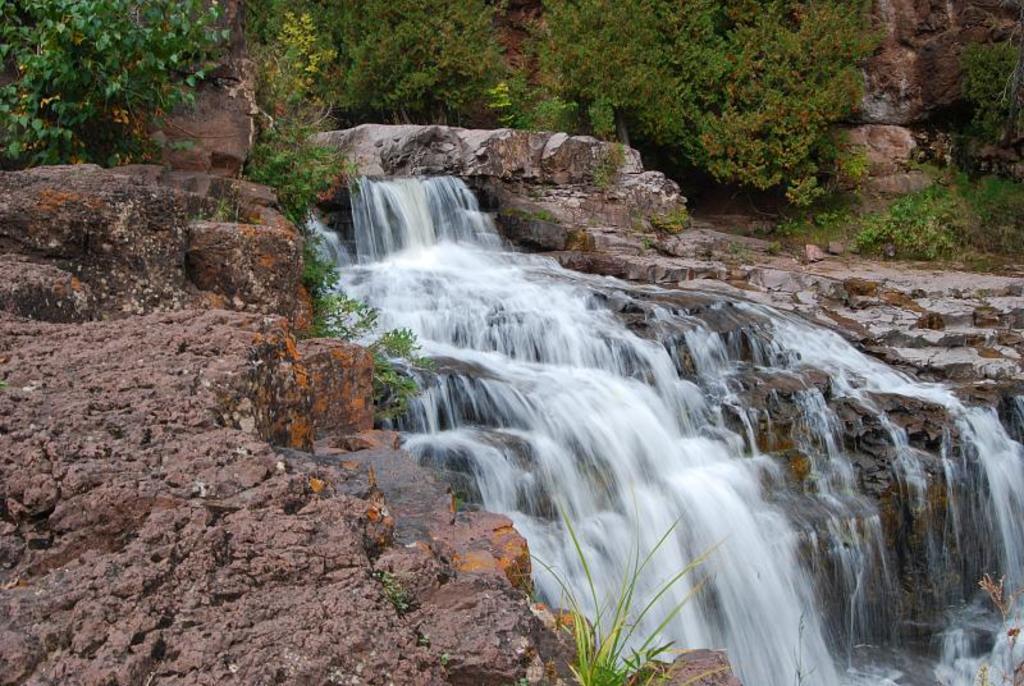Describe this image in one or two sentences. In the center of the image we can see trees, stones, plants, grass, water etc. 